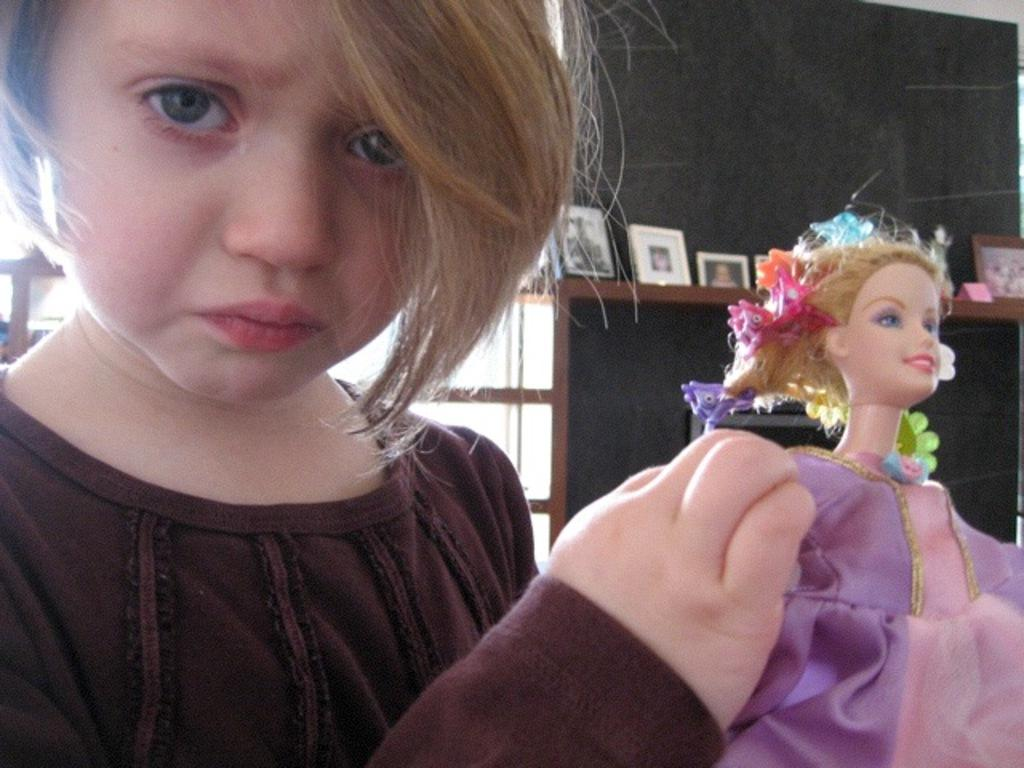What is the person in the image holding? The person is holding a doll. What is the person wearing in the image? The person is wearing a brown shirt. What can be seen in the background of the image? There are frames visible in the background. What color is the wall in the image? The wall is in gray color. What type of yoke is the person using to play chess in the image? There is no yoke or chess game present in the image. The person is holding a doll and wearing a brown shirt, with frames visible in the background and a gray wall. 